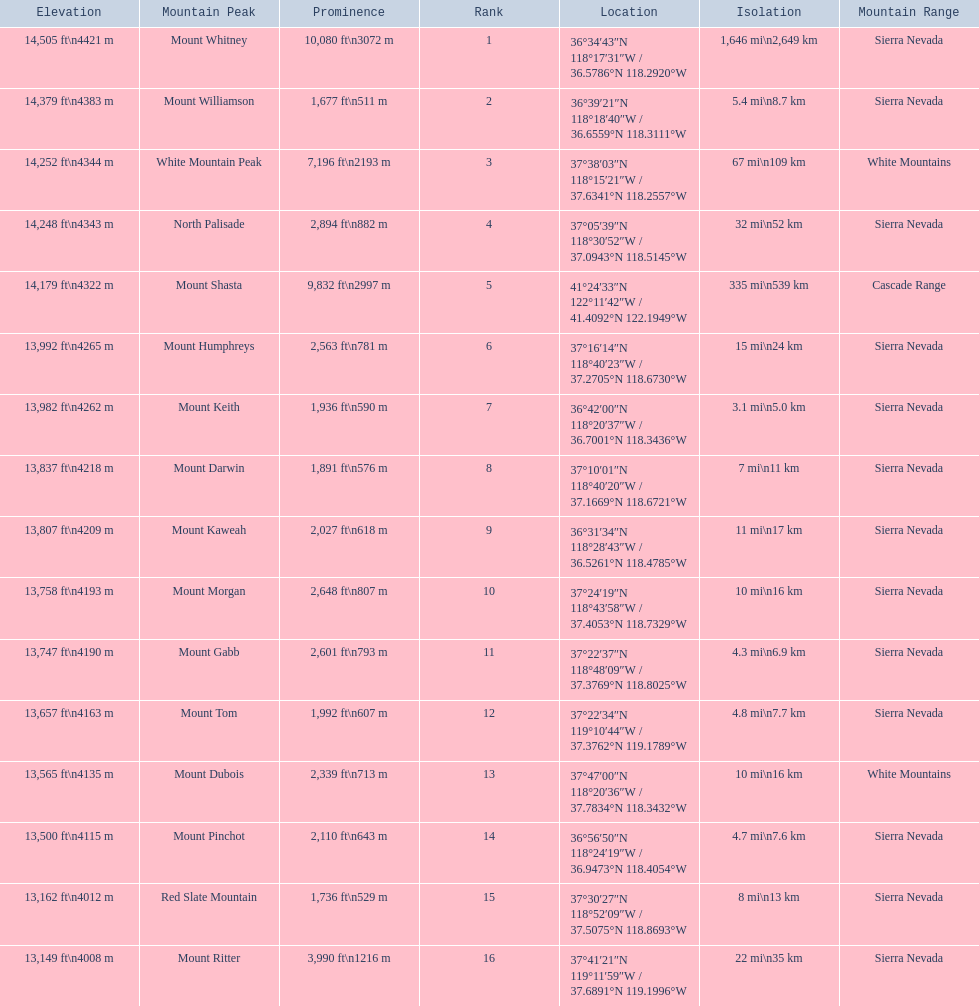What are the heights of the peaks? 14,505 ft\n4421 m, 14,379 ft\n4383 m, 14,252 ft\n4344 m, 14,248 ft\n4343 m, 14,179 ft\n4322 m, 13,992 ft\n4265 m, 13,982 ft\n4262 m, 13,837 ft\n4218 m, 13,807 ft\n4209 m, 13,758 ft\n4193 m, 13,747 ft\n4190 m, 13,657 ft\n4163 m, 13,565 ft\n4135 m, 13,500 ft\n4115 m, 13,162 ft\n4012 m, 13,149 ft\n4008 m. Which of these heights is tallest? 14,505 ft\n4421 m. What peak is 14,505 feet? Mount Whitney. 